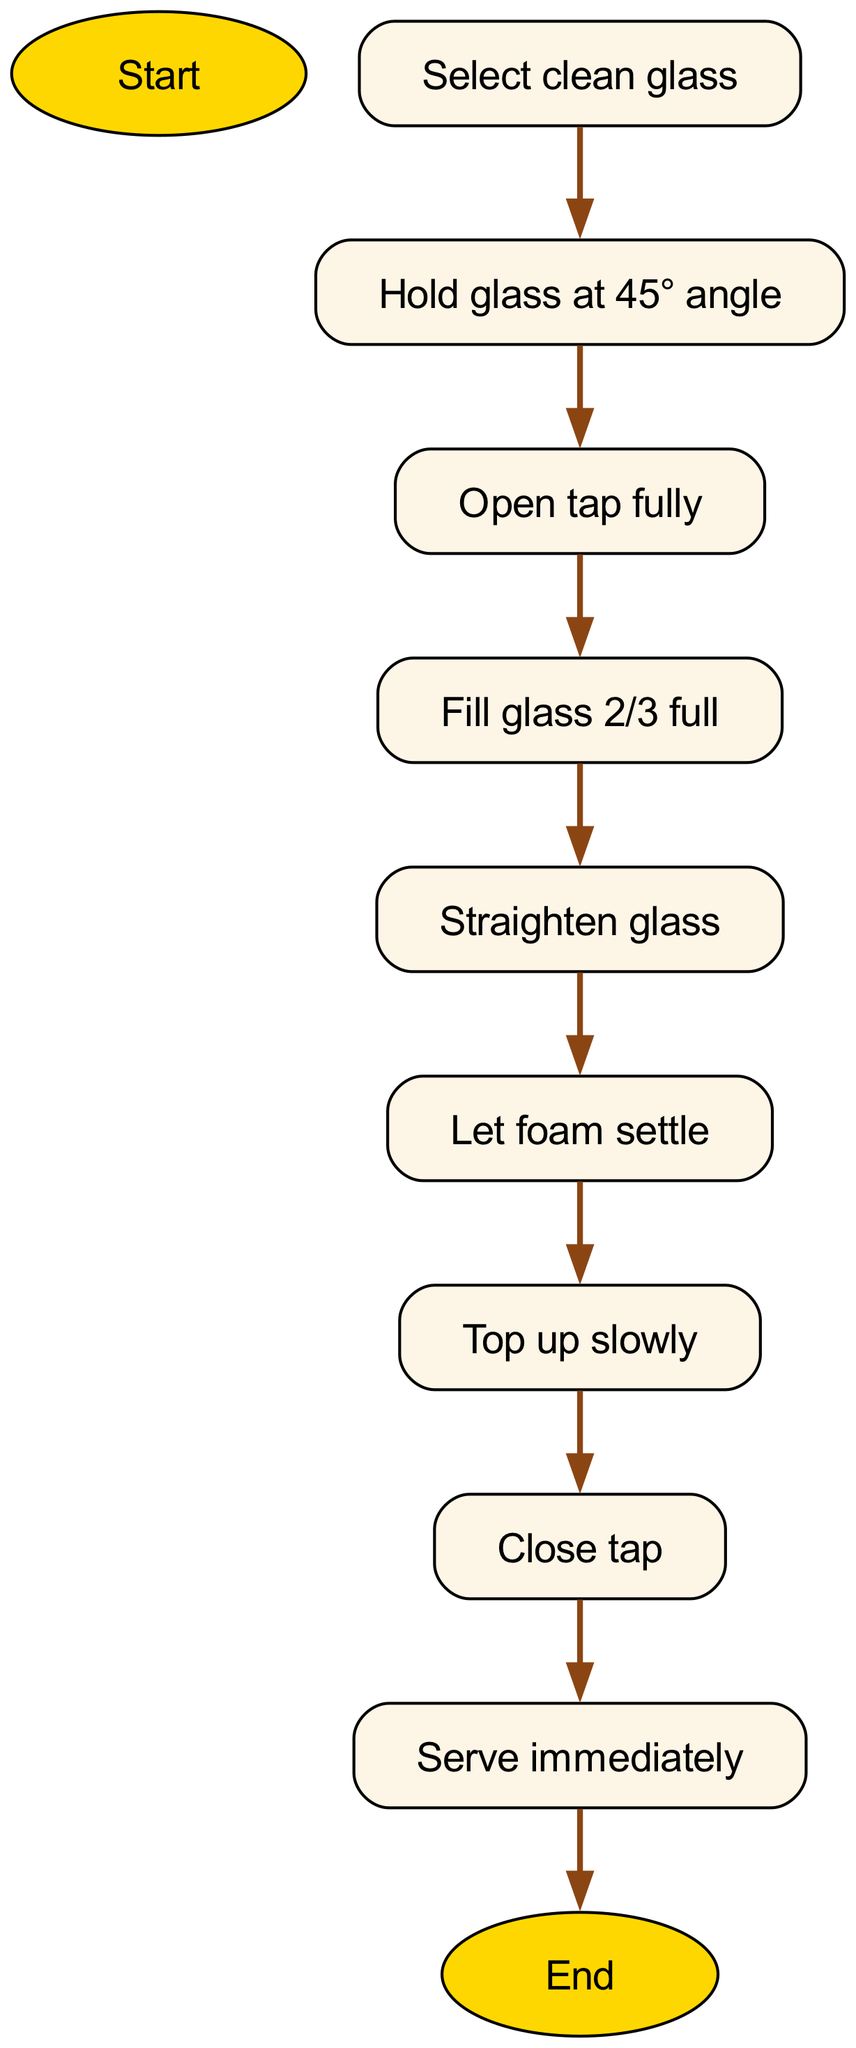What is the first step in pouring a pint? The diagram starts with "Prepare to pour" as the starting point, which is the first instruction given before any other steps.
Answer: Prepare to pour How many total steps are there to pour the perfect pint? By counting the steps in the diagram, there are 8 distinct steps listed, each leading to the next until serving.
Answer: 8 What do you do after filling the glass 2/3 full? After "Fill glass 2/3 full", the next step in the sequence as indicated by the arrows in the diagram is "Straighten glass".
Answer: Straighten glass What is the last step before serving the beer? The step right before "Serve immediately" is "Close tap"; this indicates the final action taken before delivering the beer.
Answer: Close tap How should the glass be held before opening the tap? According to the diagram, before opening the tap, one should "Hold glass at 45° angle", showing how to position the glass correctly.
Answer: Hold glass at 45° angle What is done to the foam during the process? The instruction states "Let foam settle", which indicates that after straightening the glass, there is a period where the foam is allowed to stabilize before topping up.
Answer: Let foam settle What is the relationship between "Open tap fully" and "Fill glass 2/3 full"? "Open tap fully" is a prerequisite action that leads directly to "Fill glass 2/3 full"; it shows that the former must be completed to proceed to filling the glass.
Answer: Open tap fully → Fill glass 2/3 full What is the angle at which the glass should be held initially? The recommended angle in the diagram is 45°, which gives guidance on how to start pouring correctly.
Answer: 45° angle 